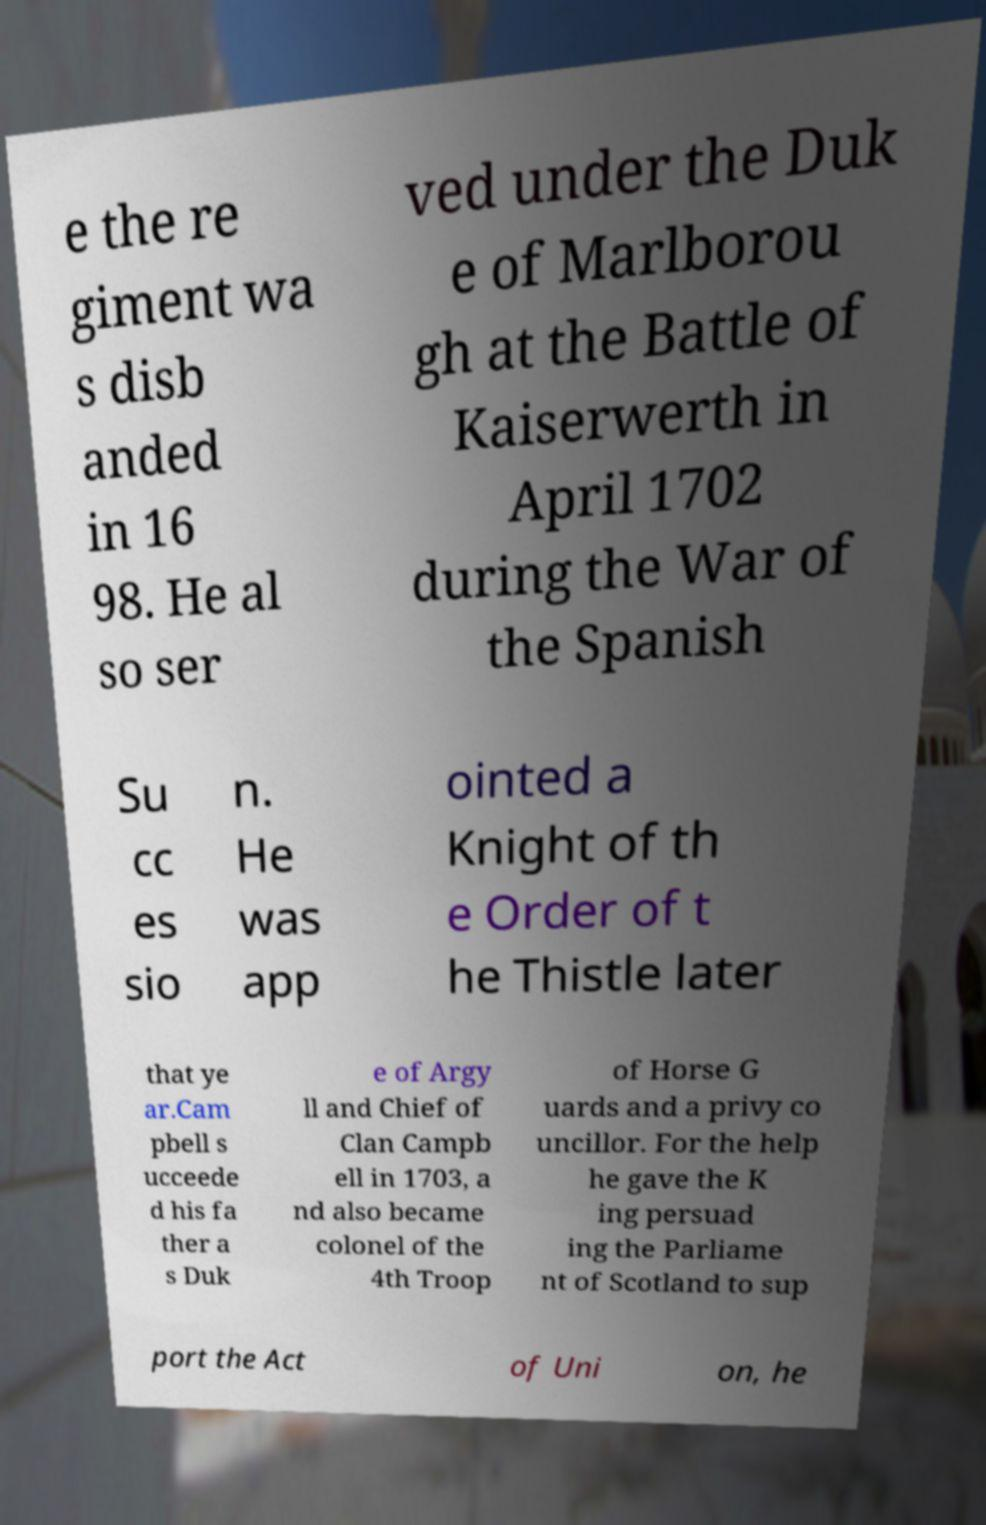Can you read and provide the text displayed in the image?This photo seems to have some interesting text. Can you extract and type it out for me? e the re giment wa s disb anded in 16 98. He al so ser ved under the Duk e of Marlborou gh at the Battle of Kaiserwerth in April 1702 during the War of the Spanish Su cc es sio n. He was app ointed a Knight of th e Order of t he Thistle later that ye ar.Cam pbell s ucceede d his fa ther a s Duk e of Argy ll and Chief of Clan Campb ell in 1703, a nd also became colonel of the 4th Troop of Horse G uards and a privy co uncillor. For the help he gave the K ing persuad ing the Parliame nt of Scotland to sup port the Act of Uni on, he 